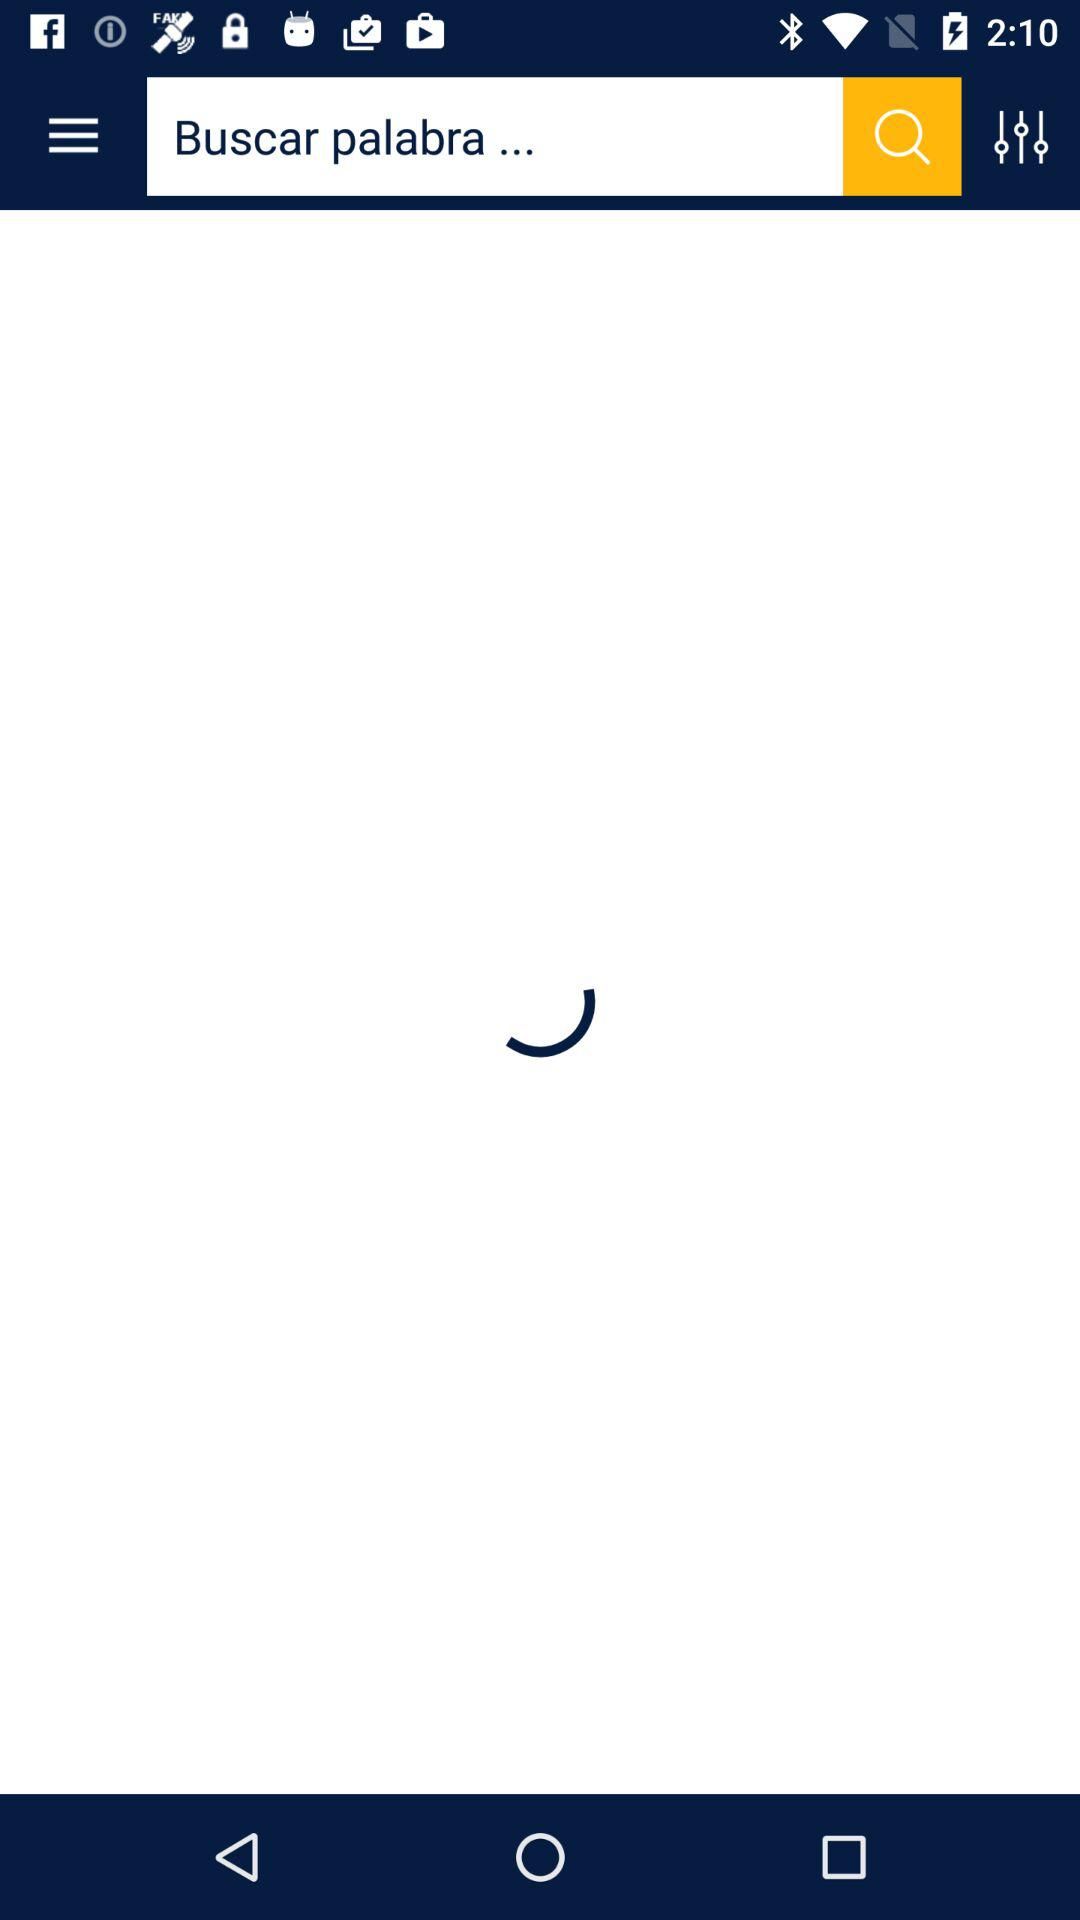What text is in the search bar? The text is "Buscar palabra...". 